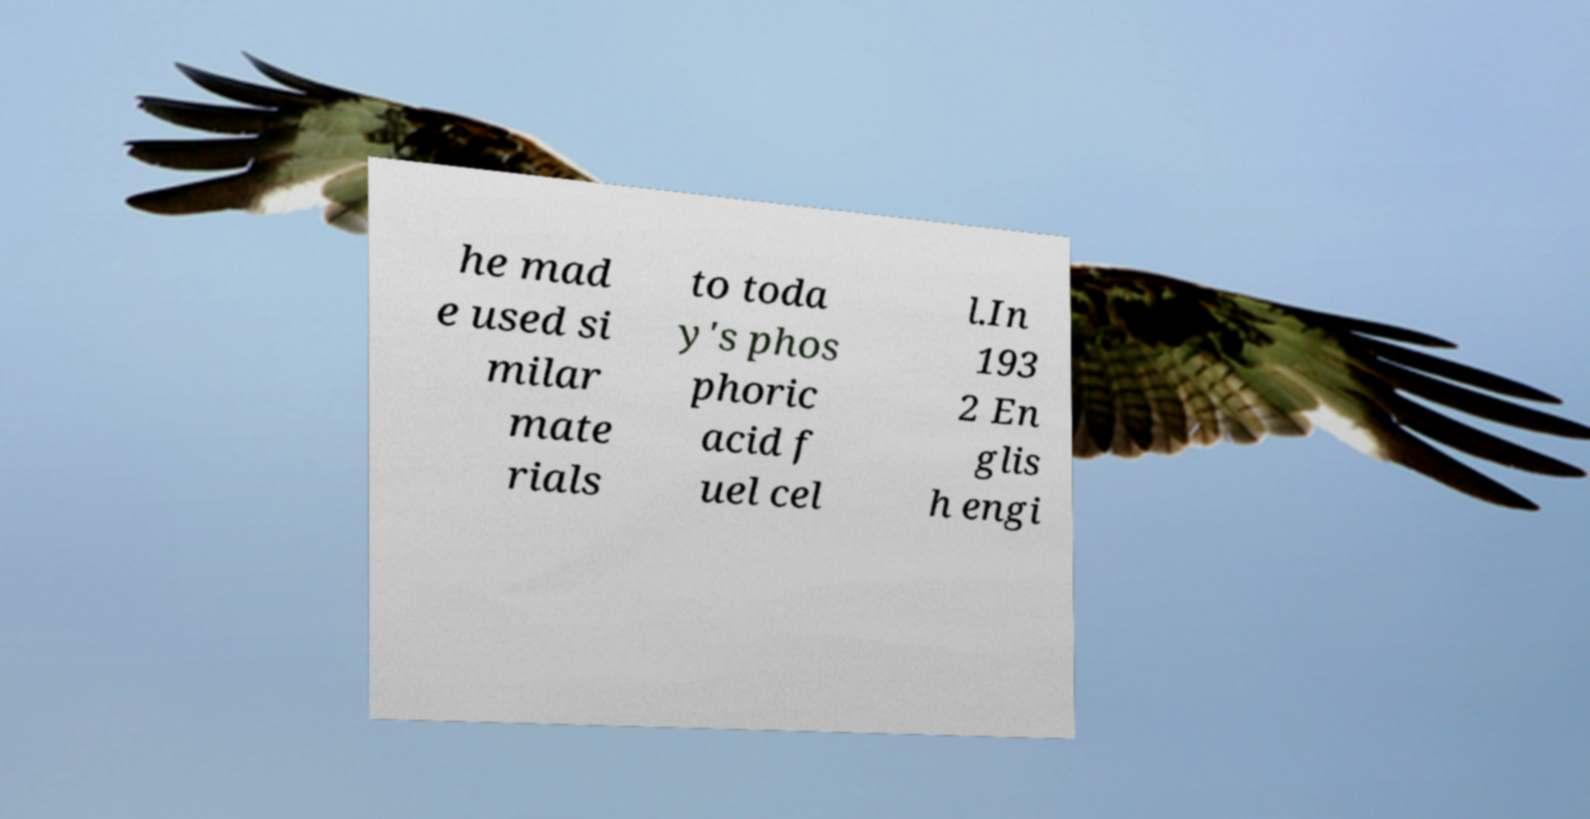There's text embedded in this image that I need extracted. Can you transcribe it verbatim? he mad e used si milar mate rials to toda y's phos phoric acid f uel cel l.In 193 2 En glis h engi 